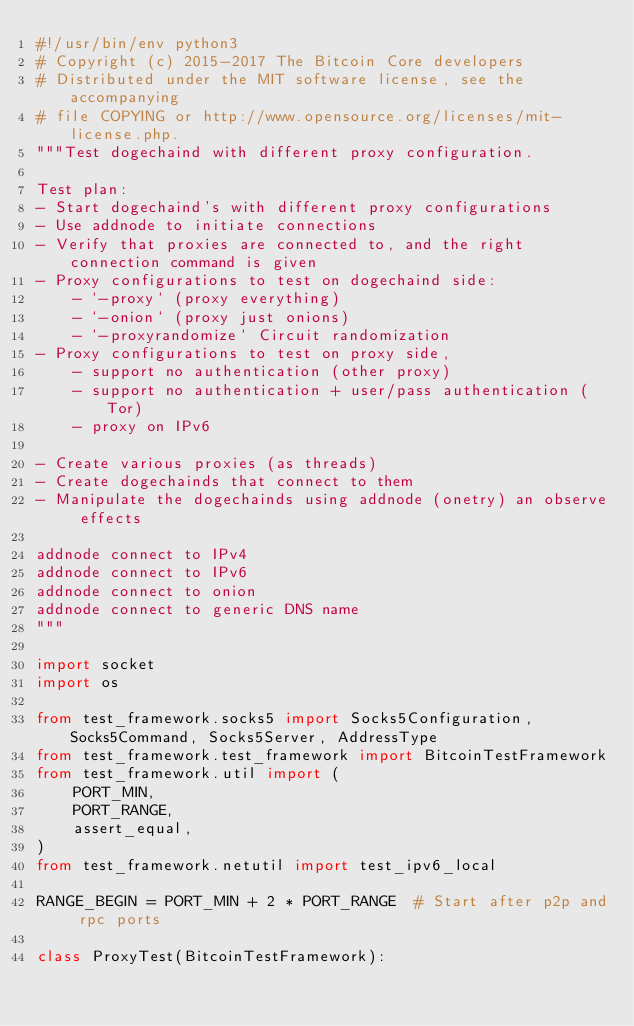<code> <loc_0><loc_0><loc_500><loc_500><_Python_>#!/usr/bin/env python3
# Copyright (c) 2015-2017 The Bitcoin Core developers
# Distributed under the MIT software license, see the accompanying
# file COPYING or http://www.opensource.org/licenses/mit-license.php.
"""Test dogechaind with different proxy configuration.

Test plan:
- Start dogechaind's with different proxy configurations
- Use addnode to initiate connections
- Verify that proxies are connected to, and the right connection command is given
- Proxy configurations to test on dogechaind side:
    - `-proxy` (proxy everything)
    - `-onion` (proxy just onions)
    - `-proxyrandomize` Circuit randomization
- Proxy configurations to test on proxy side,
    - support no authentication (other proxy)
    - support no authentication + user/pass authentication (Tor)
    - proxy on IPv6

- Create various proxies (as threads)
- Create dogechainds that connect to them
- Manipulate the dogechainds using addnode (onetry) an observe effects

addnode connect to IPv4
addnode connect to IPv6
addnode connect to onion
addnode connect to generic DNS name
"""

import socket
import os

from test_framework.socks5 import Socks5Configuration, Socks5Command, Socks5Server, AddressType
from test_framework.test_framework import BitcoinTestFramework
from test_framework.util import (
    PORT_MIN,
    PORT_RANGE,
    assert_equal,
)
from test_framework.netutil import test_ipv6_local

RANGE_BEGIN = PORT_MIN + 2 * PORT_RANGE  # Start after p2p and rpc ports

class ProxyTest(BitcoinTestFramework):</code> 